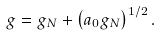Convert formula to latex. <formula><loc_0><loc_0><loc_500><loc_500>g = g _ { N } + \left ( a _ { 0 } g _ { N } \right ) ^ { 1 / 2 } .</formula> 